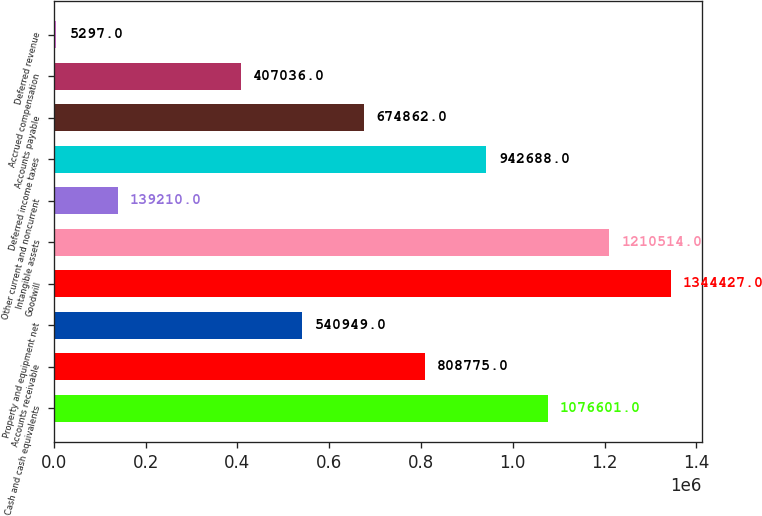<chart> <loc_0><loc_0><loc_500><loc_500><bar_chart><fcel>Cash and cash equivalents<fcel>Accounts receivable<fcel>Property and equipment net<fcel>Goodwill<fcel>Intangible assets<fcel>Other current and noncurrent<fcel>Deferred income taxes<fcel>Accounts payable<fcel>Accrued compensation<fcel>Deferred revenue<nl><fcel>1.0766e+06<fcel>808775<fcel>540949<fcel>1.34443e+06<fcel>1.21051e+06<fcel>139210<fcel>942688<fcel>674862<fcel>407036<fcel>5297<nl></chart> 